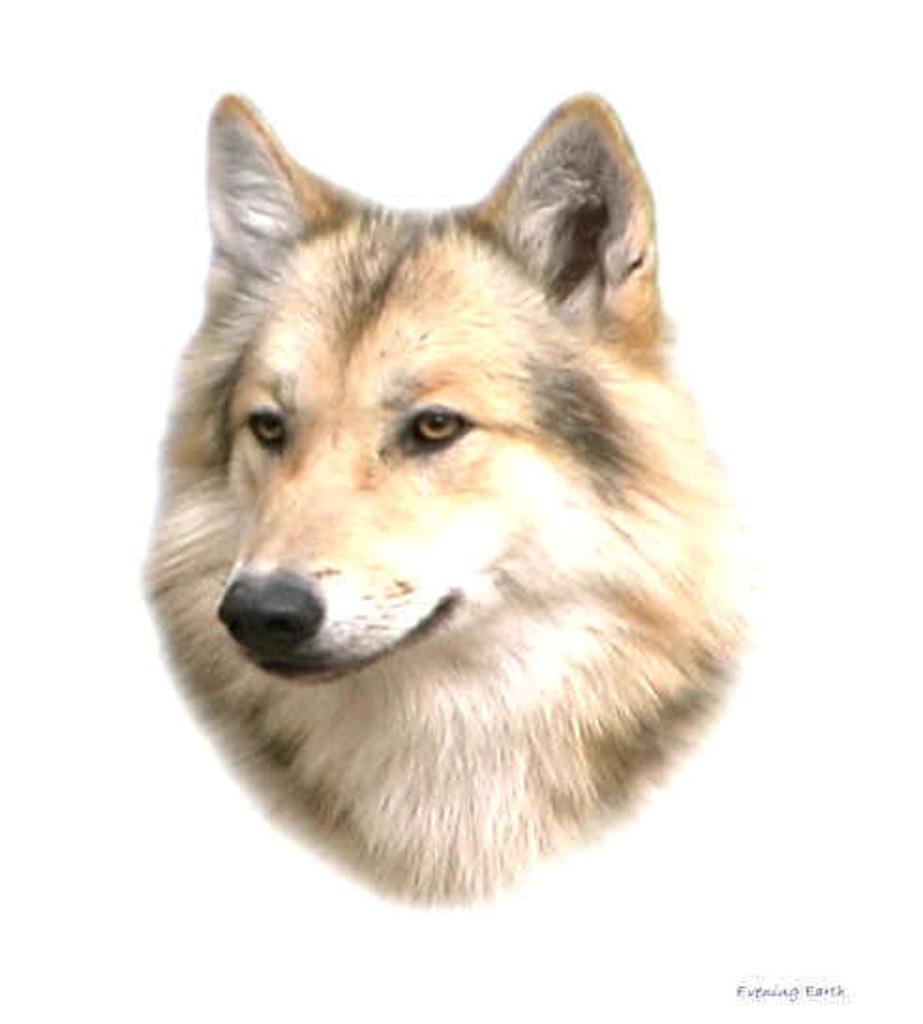Can you describe this image briefly? This is an edited image, we can see an animal face and on the image there is a watermark. 